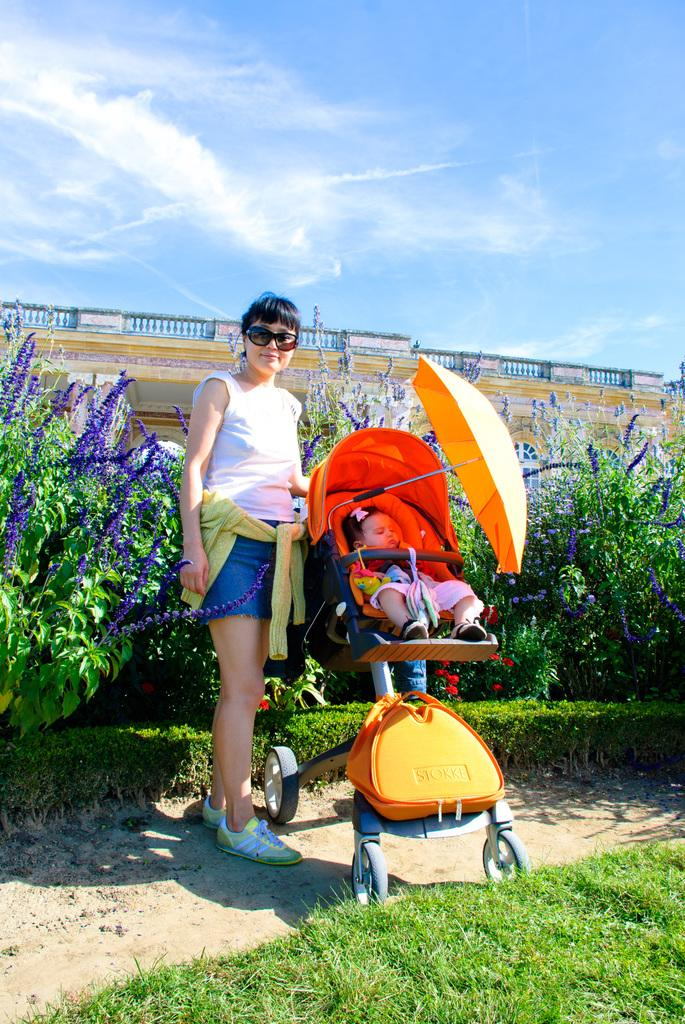What is the woman in the image wearing on her head? The woman is wearing goggles in the image. What type of clothing is the woman wearing on her upper body? The woman is wearing a white t-shirt in the image. What type of clothing is the woman wearing on her lower body? The woman is wearing shorts in the image. What is the baby in the image sitting in? The baby is in a stroller in the image. What object is present in the image to provide shade or protection from the sun? There is an umbrella in the image. What type of vegetation can be seen in the background of the image? There are flower plants in the background of the image. What type of structure is visible in the background of the image? There is a building in the background of the image. What type of pancake is the woman flipping in the image? There is no pancake present in the image, and the woman is not flipping anything. How many thumbs does the woman have in the image? The image does not show the woman's thumbs, so it cannot be determined from the image. 